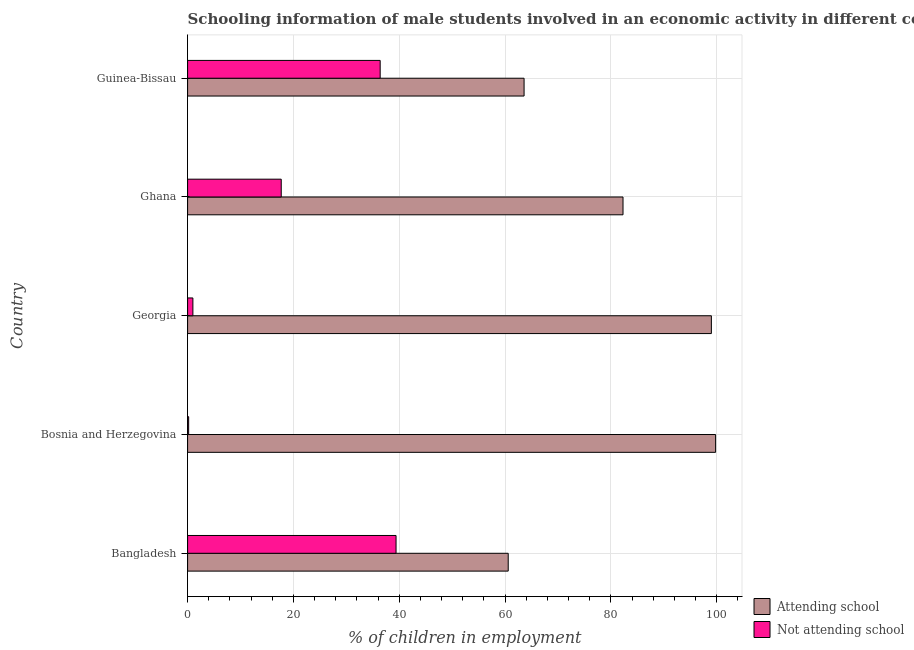How many different coloured bars are there?
Your answer should be very brief. 2. Are the number of bars per tick equal to the number of legend labels?
Offer a terse response. Yes. What is the label of the 2nd group of bars from the top?
Offer a very short reply. Ghana. In how many cases, is the number of bars for a given country not equal to the number of legend labels?
Keep it short and to the point. 0. What is the percentage of employed males who are attending school in Bangladesh?
Your response must be concise. 60.6. Across all countries, what is the maximum percentage of employed males who are attending school?
Your answer should be very brief. 99.8. Across all countries, what is the minimum percentage of employed males who are attending school?
Ensure brevity in your answer.  60.6. What is the total percentage of employed males who are attending school in the graph?
Provide a short and direct response. 405.3. What is the difference between the percentage of employed males who are attending school in Bangladesh and that in Guinea-Bissau?
Ensure brevity in your answer.  -3. What is the difference between the percentage of employed males who are not attending school in Bangladesh and the percentage of employed males who are attending school in Georgia?
Offer a terse response. -59.6. What is the average percentage of employed males who are attending school per country?
Provide a succinct answer. 81.06. What is the difference between the percentage of employed males who are attending school and percentage of employed males who are not attending school in Guinea-Bissau?
Offer a terse response. 27.2. In how many countries, is the percentage of employed males who are attending school greater than 100 %?
Provide a succinct answer. 0. What is the ratio of the percentage of employed males who are not attending school in Bosnia and Herzegovina to that in Ghana?
Give a very brief answer. 0.01. Is the percentage of employed males who are attending school in Ghana less than that in Guinea-Bissau?
Your answer should be compact. No. Is the difference between the percentage of employed males who are not attending school in Bosnia and Herzegovina and Guinea-Bissau greater than the difference between the percentage of employed males who are attending school in Bosnia and Herzegovina and Guinea-Bissau?
Provide a succinct answer. No. What is the difference between the highest and the lowest percentage of employed males who are attending school?
Offer a terse response. 39.2. Is the sum of the percentage of employed males who are attending school in Bangladesh and Ghana greater than the maximum percentage of employed males who are not attending school across all countries?
Your response must be concise. Yes. What does the 1st bar from the top in Bosnia and Herzegovina represents?
Provide a succinct answer. Not attending school. What does the 2nd bar from the bottom in Bosnia and Herzegovina represents?
Your answer should be very brief. Not attending school. Are all the bars in the graph horizontal?
Offer a terse response. Yes. What is the difference between two consecutive major ticks on the X-axis?
Your response must be concise. 20. Are the values on the major ticks of X-axis written in scientific E-notation?
Your response must be concise. No. Does the graph contain any zero values?
Keep it short and to the point. No. Where does the legend appear in the graph?
Offer a very short reply. Bottom right. What is the title of the graph?
Offer a very short reply. Schooling information of male students involved in an economic activity in different countries. What is the label or title of the X-axis?
Provide a succinct answer. % of children in employment. What is the % of children in employment in Attending school in Bangladesh?
Offer a very short reply. 60.6. What is the % of children in employment of Not attending school in Bangladesh?
Offer a terse response. 39.4. What is the % of children in employment of Attending school in Bosnia and Herzegovina?
Provide a succinct answer. 99.8. What is the % of children in employment of Not attending school in Bosnia and Herzegovina?
Make the answer very short. 0.2. What is the % of children in employment of Attending school in Ghana?
Your response must be concise. 82.3. What is the % of children in employment in Attending school in Guinea-Bissau?
Give a very brief answer. 63.6. What is the % of children in employment in Not attending school in Guinea-Bissau?
Your answer should be compact. 36.4. Across all countries, what is the maximum % of children in employment in Attending school?
Offer a terse response. 99.8. Across all countries, what is the maximum % of children in employment in Not attending school?
Make the answer very short. 39.4. Across all countries, what is the minimum % of children in employment of Attending school?
Your response must be concise. 60.6. What is the total % of children in employment of Attending school in the graph?
Make the answer very short. 405.3. What is the total % of children in employment in Not attending school in the graph?
Make the answer very short. 94.7. What is the difference between the % of children in employment in Attending school in Bangladesh and that in Bosnia and Herzegovina?
Your response must be concise. -39.2. What is the difference between the % of children in employment in Not attending school in Bangladesh and that in Bosnia and Herzegovina?
Your answer should be compact. 39.2. What is the difference between the % of children in employment in Attending school in Bangladesh and that in Georgia?
Ensure brevity in your answer.  -38.4. What is the difference between the % of children in employment in Not attending school in Bangladesh and that in Georgia?
Provide a short and direct response. 38.4. What is the difference between the % of children in employment in Attending school in Bangladesh and that in Ghana?
Offer a terse response. -21.7. What is the difference between the % of children in employment of Not attending school in Bangladesh and that in Ghana?
Your answer should be very brief. 21.7. What is the difference between the % of children in employment in Not attending school in Bosnia and Herzegovina and that in Georgia?
Provide a succinct answer. -0.8. What is the difference between the % of children in employment of Attending school in Bosnia and Herzegovina and that in Ghana?
Make the answer very short. 17.5. What is the difference between the % of children in employment of Not attending school in Bosnia and Herzegovina and that in Ghana?
Provide a succinct answer. -17.5. What is the difference between the % of children in employment in Attending school in Bosnia and Herzegovina and that in Guinea-Bissau?
Provide a short and direct response. 36.2. What is the difference between the % of children in employment of Not attending school in Bosnia and Herzegovina and that in Guinea-Bissau?
Your answer should be compact. -36.2. What is the difference between the % of children in employment in Attending school in Georgia and that in Ghana?
Offer a very short reply. 16.7. What is the difference between the % of children in employment of Not attending school in Georgia and that in Ghana?
Your answer should be very brief. -16.7. What is the difference between the % of children in employment of Attending school in Georgia and that in Guinea-Bissau?
Make the answer very short. 35.4. What is the difference between the % of children in employment of Not attending school in Georgia and that in Guinea-Bissau?
Offer a very short reply. -35.4. What is the difference between the % of children in employment of Attending school in Ghana and that in Guinea-Bissau?
Give a very brief answer. 18.7. What is the difference between the % of children in employment in Not attending school in Ghana and that in Guinea-Bissau?
Give a very brief answer. -18.7. What is the difference between the % of children in employment of Attending school in Bangladesh and the % of children in employment of Not attending school in Bosnia and Herzegovina?
Your response must be concise. 60.4. What is the difference between the % of children in employment of Attending school in Bangladesh and the % of children in employment of Not attending school in Georgia?
Keep it short and to the point. 59.6. What is the difference between the % of children in employment in Attending school in Bangladesh and the % of children in employment in Not attending school in Ghana?
Your answer should be compact. 42.9. What is the difference between the % of children in employment in Attending school in Bangladesh and the % of children in employment in Not attending school in Guinea-Bissau?
Provide a short and direct response. 24.2. What is the difference between the % of children in employment in Attending school in Bosnia and Herzegovina and the % of children in employment in Not attending school in Georgia?
Provide a short and direct response. 98.8. What is the difference between the % of children in employment in Attending school in Bosnia and Herzegovina and the % of children in employment in Not attending school in Ghana?
Ensure brevity in your answer.  82.1. What is the difference between the % of children in employment in Attending school in Bosnia and Herzegovina and the % of children in employment in Not attending school in Guinea-Bissau?
Offer a very short reply. 63.4. What is the difference between the % of children in employment in Attending school in Georgia and the % of children in employment in Not attending school in Ghana?
Make the answer very short. 81.3. What is the difference between the % of children in employment of Attending school in Georgia and the % of children in employment of Not attending school in Guinea-Bissau?
Your answer should be compact. 62.6. What is the difference between the % of children in employment in Attending school in Ghana and the % of children in employment in Not attending school in Guinea-Bissau?
Your answer should be compact. 45.9. What is the average % of children in employment in Attending school per country?
Ensure brevity in your answer.  81.06. What is the average % of children in employment of Not attending school per country?
Make the answer very short. 18.94. What is the difference between the % of children in employment in Attending school and % of children in employment in Not attending school in Bangladesh?
Your response must be concise. 21.2. What is the difference between the % of children in employment in Attending school and % of children in employment in Not attending school in Bosnia and Herzegovina?
Provide a succinct answer. 99.6. What is the difference between the % of children in employment in Attending school and % of children in employment in Not attending school in Georgia?
Offer a terse response. 98. What is the difference between the % of children in employment in Attending school and % of children in employment in Not attending school in Ghana?
Provide a succinct answer. 64.6. What is the difference between the % of children in employment of Attending school and % of children in employment of Not attending school in Guinea-Bissau?
Your answer should be compact. 27.2. What is the ratio of the % of children in employment in Attending school in Bangladesh to that in Bosnia and Herzegovina?
Give a very brief answer. 0.61. What is the ratio of the % of children in employment of Not attending school in Bangladesh to that in Bosnia and Herzegovina?
Make the answer very short. 197. What is the ratio of the % of children in employment of Attending school in Bangladesh to that in Georgia?
Offer a very short reply. 0.61. What is the ratio of the % of children in employment in Not attending school in Bangladesh to that in Georgia?
Provide a short and direct response. 39.4. What is the ratio of the % of children in employment of Attending school in Bangladesh to that in Ghana?
Keep it short and to the point. 0.74. What is the ratio of the % of children in employment in Not attending school in Bangladesh to that in Ghana?
Offer a very short reply. 2.23. What is the ratio of the % of children in employment of Attending school in Bangladesh to that in Guinea-Bissau?
Offer a very short reply. 0.95. What is the ratio of the % of children in employment in Not attending school in Bangladesh to that in Guinea-Bissau?
Your answer should be compact. 1.08. What is the ratio of the % of children in employment of Attending school in Bosnia and Herzegovina to that in Georgia?
Offer a very short reply. 1.01. What is the ratio of the % of children in employment in Not attending school in Bosnia and Herzegovina to that in Georgia?
Your response must be concise. 0.2. What is the ratio of the % of children in employment in Attending school in Bosnia and Herzegovina to that in Ghana?
Offer a very short reply. 1.21. What is the ratio of the % of children in employment of Not attending school in Bosnia and Herzegovina to that in Ghana?
Provide a succinct answer. 0.01. What is the ratio of the % of children in employment of Attending school in Bosnia and Herzegovina to that in Guinea-Bissau?
Ensure brevity in your answer.  1.57. What is the ratio of the % of children in employment of Not attending school in Bosnia and Herzegovina to that in Guinea-Bissau?
Provide a short and direct response. 0.01. What is the ratio of the % of children in employment of Attending school in Georgia to that in Ghana?
Your answer should be very brief. 1.2. What is the ratio of the % of children in employment of Not attending school in Georgia to that in Ghana?
Keep it short and to the point. 0.06. What is the ratio of the % of children in employment in Attending school in Georgia to that in Guinea-Bissau?
Offer a very short reply. 1.56. What is the ratio of the % of children in employment of Not attending school in Georgia to that in Guinea-Bissau?
Make the answer very short. 0.03. What is the ratio of the % of children in employment of Attending school in Ghana to that in Guinea-Bissau?
Provide a short and direct response. 1.29. What is the ratio of the % of children in employment of Not attending school in Ghana to that in Guinea-Bissau?
Provide a short and direct response. 0.49. What is the difference between the highest and the second highest % of children in employment in Attending school?
Provide a short and direct response. 0.8. What is the difference between the highest and the lowest % of children in employment in Attending school?
Your answer should be very brief. 39.2. What is the difference between the highest and the lowest % of children in employment of Not attending school?
Your answer should be compact. 39.2. 